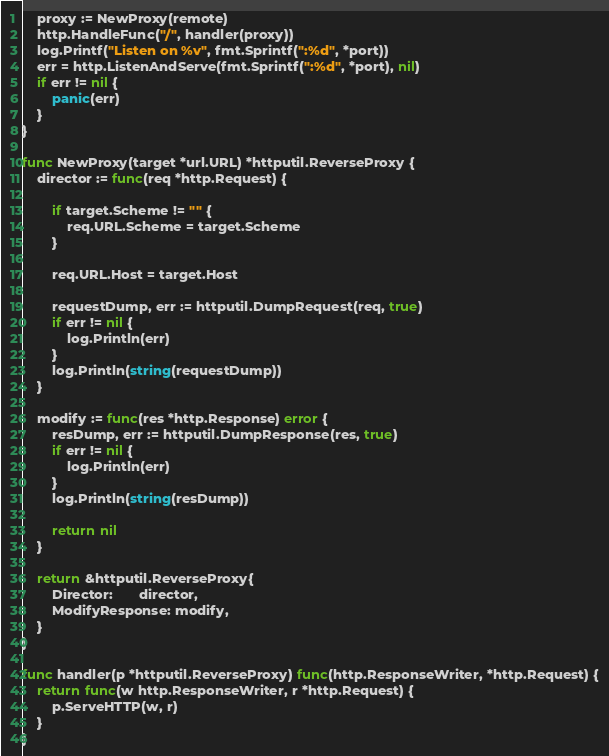Convert code to text. <code><loc_0><loc_0><loc_500><loc_500><_Go_>	proxy := NewProxy(remote)
	http.HandleFunc("/", handler(proxy))
	log.Printf("Listen on %v", fmt.Sprintf(":%d", *port))
	err = http.ListenAndServe(fmt.Sprintf(":%d", *port), nil)
	if err != nil {
		panic(err)
	}
}

func NewProxy(target *url.URL) *httputil.ReverseProxy {
	director := func(req *http.Request) {

		if target.Scheme != "" {
			req.URL.Scheme = target.Scheme
		}

		req.URL.Host = target.Host

		requestDump, err := httputil.DumpRequest(req, true)
		if err != nil {
			log.Println(err)
		}
		log.Println(string(requestDump))
	}

	modify := func(res *http.Response) error {
		resDump, err := httputil.DumpResponse(res, true)
		if err != nil {
			log.Println(err)
		}
		log.Println(string(resDump))

		return nil
	}

	return &httputil.ReverseProxy{
		Director:       director,
		ModifyResponse: modify,
	}
}

func handler(p *httputil.ReverseProxy) func(http.ResponseWriter, *http.Request) {
	return func(w http.ResponseWriter, r *http.Request) {
		p.ServeHTTP(w, r)
	}
}
</code> 